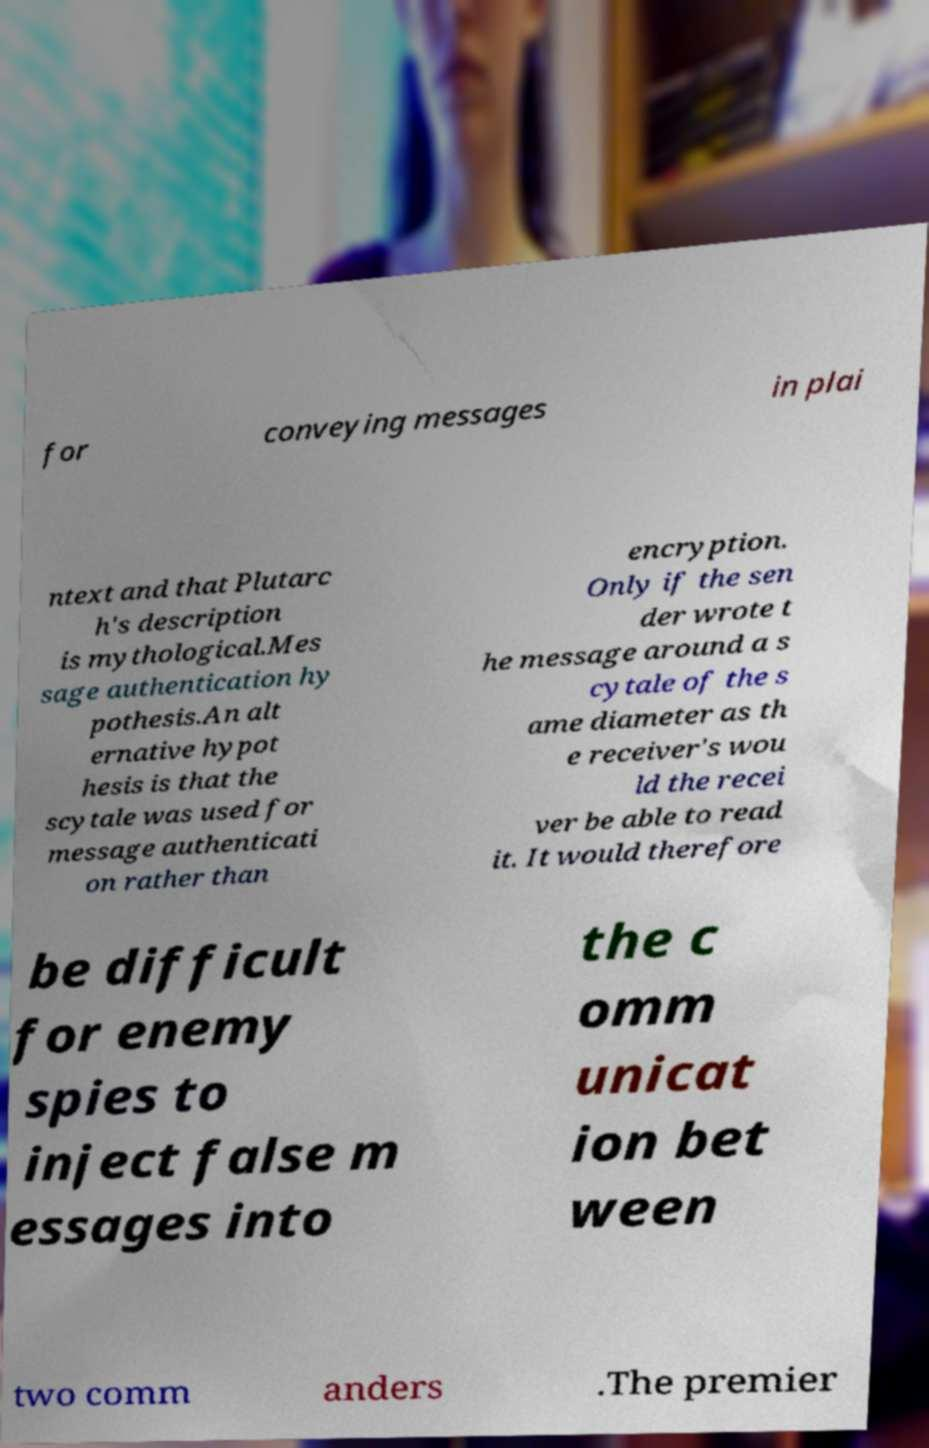Can you accurately transcribe the text from the provided image for me? for conveying messages in plai ntext and that Plutarc h's description is mythological.Mes sage authentication hy pothesis.An alt ernative hypot hesis is that the scytale was used for message authenticati on rather than encryption. Only if the sen der wrote t he message around a s cytale of the s ame diameter as th e receiver's wou ld the recei ver be able to read it. It would therefore be difficult for enemy spies to inject false m essages into the c omm unicat ion bet ween two comm anders .The premier 